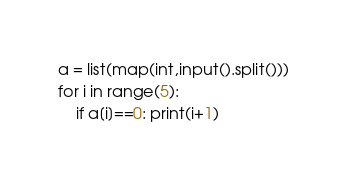Convert code to text. <code><loc_0><loc_0><loc_500><loc_500><_Python_>a = list(map(int,input().split()))
for i in range(5):
    if a[i]==0: print(i+1)</code> 